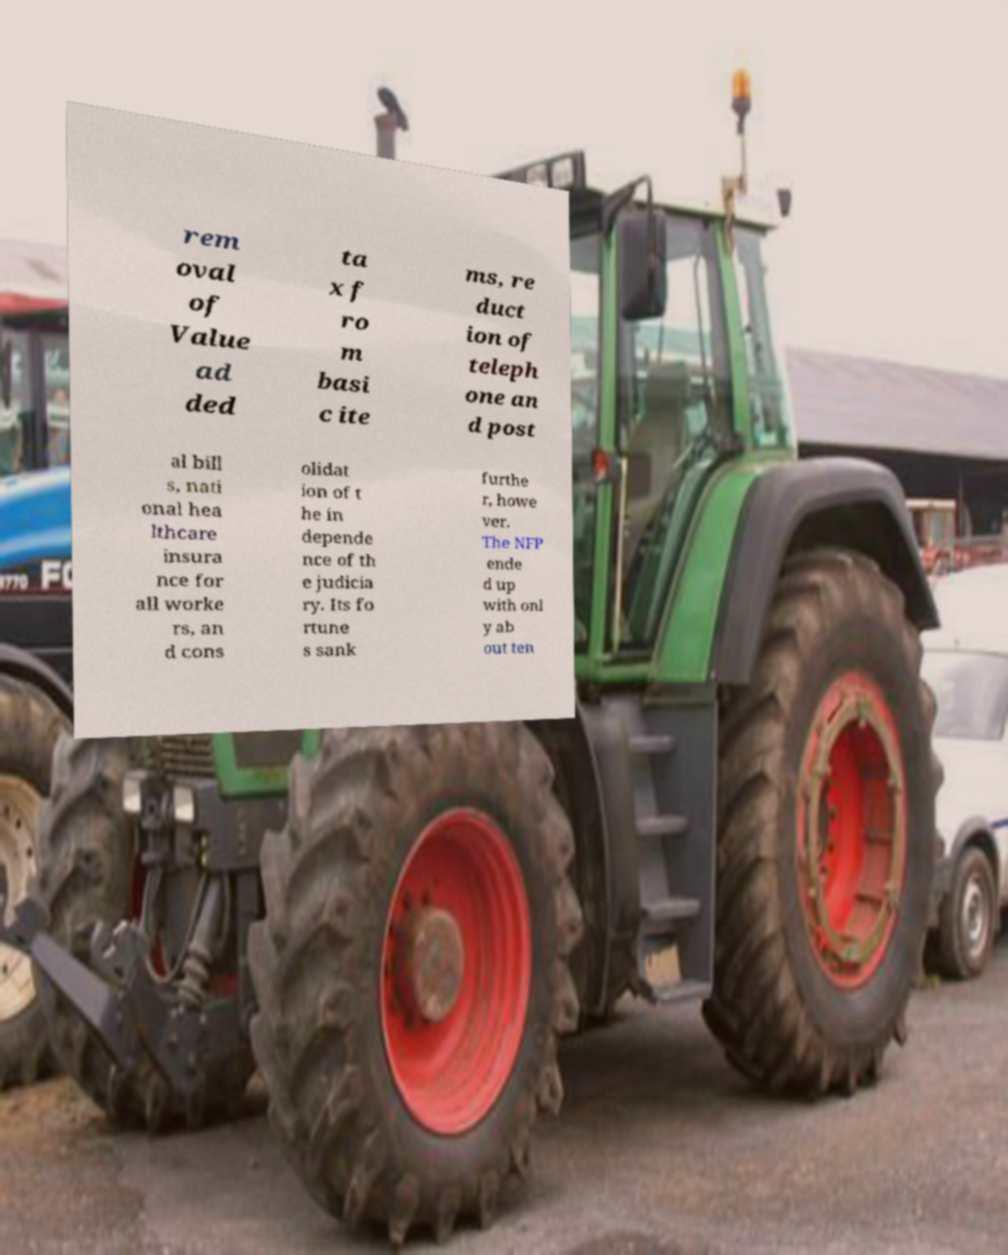Can you read and provide the text displayed in the image?This photo seems to have some interesting text. Can you extract and type it out for me? rem oval of Value ad ded ta x f ro m basi c ite ms, re duct ion of teleph one an d post al bill s, nati onal hea lthcare insura nce for all worke rs, an d cons olidat ion of t he in depende nce of th e judicia ry. Its fo rtune s sank furthe r, howe ver. The NFP ende d up with onl y ab out ten 